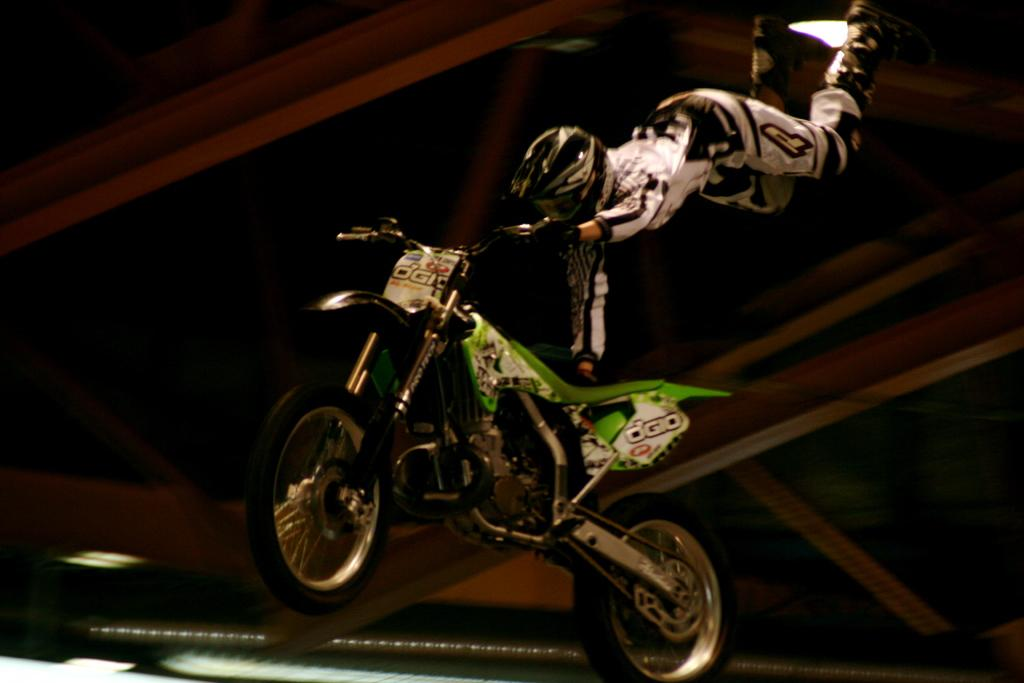What type of vehicle is on the floor in the image? There is a motorcycle on the floor in the image. What is the person in the image doing with the motorcycle? The person is holding the handle of the motorcycle. What is unusual about the person's position in the image? The person appears to be flying in the air. Where is the faucet located in the image? There is no faucet present in the image. What type of attraction is the person visiting in the image? The image does not depict a specific attraction; it simply shows a person holding a motorcycle handle while flying in the air. 